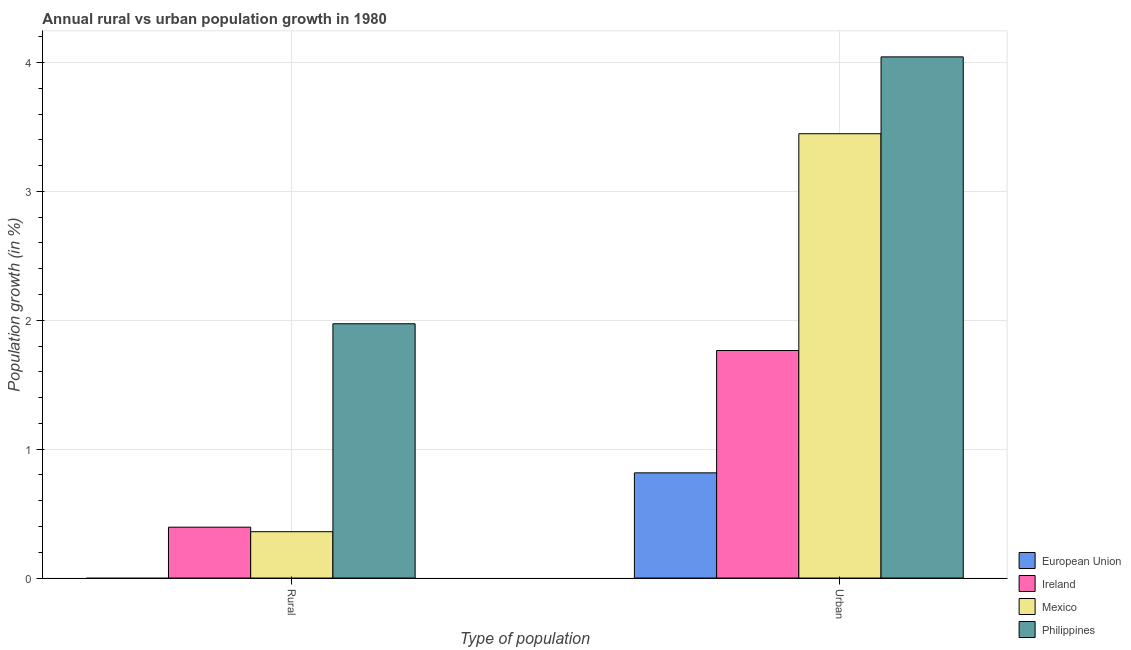How many different coloured bars are there?
Provide a short and direct response. 4. Are the number of bars on each tick of the X-axis equal?
Make the answer very short. No. How many bars are there on the 2nd tick from the right?
Keep it short and to the point. 3. What is the label of the 1st group of bars from the left?
Keep it short and to the point. Rural. What is the urban population growth in Mexico?
Your answer should be very brief. 3.45. Across all countries, what is the maximum rural population growth?
Ensure brevity in your answer.  1.97. Across all countries, what is the minimum rural population growth?
Provide a short and direct response. 0. In which country was the rural population growth maximum?
Keep it short and to the point. Philippines. What is the total urban population growth in the graph?
Give a very brief answer. 10.07. What is the difference between the rural population growth in Ireland and that in Mexico?
Your answer should be very brief. 0.04. What is the difference between the urban population growth in Ireland and the rural population growth in Philippines?
Provide a succinct answer. -0.21. What is the average urban population growth per country?
Your response must be concise. 2.52. What is the difference between the urban population growth and rural population growth in Philippines?
Provide a short and direct response. 2.07. What is the ratio of the urban population growth in Mexico to that in Philippines?
Your answer should be compact. 0.85. In how many countries, is the rural population growth greater than the average rural population growth taken over all countries?
Provide a succinct answer. 1. How many bars are there?
Your answer should be very brief. 7. Are all the bars in the graph horizontal?
Your answer should be compact. No. How many countries are there in the graph?
Offer a terse response. 4. What is the difference between two consecutive major ticks on the Y-axis?
Your answer should be very brief. 1. Are the values on the major ticks of Y-axis written in scientific E-notation?
Your answer should be very brief. No. Does the graph contain any zero values?
Provide a short and direct response. Yes. Where does the legend appear in the graph?
Provide a short and direct response. Bottom right. What is the title of the graph?
Make the answer very short. Annual rural vs urban population growth in 1980. What is the label or title of the X-axis?
Provide a succinct answer. Type of population. What is the label or title of the Y-axis?
Ensure brevity in your answer.  Population growth (in %). What is the Population growth (in %) of European Union in Rural?
Your answer should be compact. 0. What is the Population growth (in %) in Ireland in Rural?
Ensure brevity in your answer.  0.39. What is the Population growth (in %) of Mexico in Rural?
Offer a very short reply. 0.36. What is the Population growth (in %) in Philippines in Rural?
Provide a short and direct response. 1.97. What is the Population growth (in %) of European Union in Urban ?
Provide a succinct answer. 0.82. What is the Population growth (in %) of Ireland in Urban ?
Ensure brevity in your answer.  1.77. What is the Population growth (in %) in Mexico in Urban ?
Offer a very short reply. 3.45. What is the Population growth (in %) of Philippines in Urban ?
Make the answer very short. 4.04. Across all Type of population, what is the maximum Population growth (in %) in European Union?
Give a very brief answer. 0.82. Across all Type of population, what is the maximum Population growth (in %) of Ireland?
Provide a succinct answer. 1.77. Across all Type of population, what is the maximum Population growth (in %) of Mexico?
Your answer should be very brief. 3.45. Across all Type of population, what is the maximum Population growth (in %) in Philippines?
Ensure brevity in your answer.  4.04. Across all Type of population, what is the minimum Population growth (in %) in Ireland?
Provide a short and direct response. 0.39. Across all Type of population, what is the minimum Population growth (in %) of Mexico?
Provide a succinct answer. 0.36. Across all Type of population, what is the minimum Population growth (in %) in Philippines?
Provide a succinct answer. 1.97. What is the total Population growth (in %) of European Union in the graph?
Make the answer very short. 0.82. What is the total Population growth (in %) in Ireland in the graph?
Ensure brevity in your answer.  2.16. What is the total Population growth (in %) of Mexico in the graph?
Make the answer very short. 3.81. What is the total Population growth (in %) in Philippines in the graph?
Your answer should be very brief. 6.02. What is the difference between the Population growth (in %) of Ireland in Rural and that in Urban ?
Make the answer very short. -1.37. What is the difference between the Population growth (in %) of Mexico in Rural and that in Urban ?
Your answer should be very brief. -3.09. What is the difference between the Population growth (in %) of Philippines in Rural and that in Urban ?
Offer a very short reply. -2.07. What is the difference between the Population growth (in %) in Ireland in Rural and the Population growth (in %) in Mexico in Urban?
Offer a terse response. -3.05. What is the difference between the Population growth (in %) in Ireland in Rural and the Population growth (in %) in Philippines in Urban?
Provide a short and direct response. -3.65. What is the difference between the Population growth (in %) of Mexico in Rural and the Population growth (in %) of Philippines in Urban?
Your answer should be compact. -3.68. What is the average Population growth (in %) of European Union per Type of population?
Provide a succinct answer. 0.41. What is the average Population growth (in %) in Ireland per Type of population?
Ensure brevity in your answer.  1.08. What is the average Population growth (in %) of Mexico per Type of population?
Keep it short and to the point. 1.9. What is the average Population growth (in %) in Philippines per Type of population?
Keep it short and to the point. 3.01. What is the difference between the Population growth (in %) in Ireland and Population growth (in %) in Mexico in Rural?
Offer a terse response. 0.04. What is the difference between the Population growth (in %) in Ireland and Population growth (in %) in Philippines in Rural?
Give a very brief answer. -1.58. What is the difference between the Population growth (in %) of Mexico and Population growth (in %) of Philippines in Rural?
Your response must be concise. -1.61. What is the difference between the Population growth (in %) of European Union and Population growth (in %) of Ireland in Urban ?
Ensure brevity in your answer.  -0.95. What is the difference between the Population growth (in %) of European Union and Population growth (in %) of Mexico in Urban ?
Ensure brevity in your answer.  -2.63. What is the difference between the Population growth (in %) in European Union and Population growth (in %) in Philippines in Urban ?
Offer a terse response. -3.23. What is the difference between the Population growth (in %) of Ireland and Population growth (in %) of Mexico in Urban ?
Offer a terse response. -1.68. What is the difference between the Population growth (in %) in Ireland and Population growth (in %) in Philippines in Urban ?
Your answer should be very brief. -2.28. What is the difference between the Population growth (in %) of Mexico and Population growth (in %) of Philippines in Urban ?
Your response must be concise. -0.6. What is the ratio of the Population growth (in %) in Ireland in Rural to that in Urban ?
Make the answer very short. 0.22. What is the ratio of the Population growth (in %) in Mexico in Rural to that in Urban ?
Offer a very short reply. 0.1. What is the ratio of the Population growth (in %) of Philippines in Rural to that in Urban ?
Your answer should be compact. 0.49. What is the difference between the highest and the second highest Population growth (in %) in Ireland?
Your answer should be compact. 1.37. What is the difference between the highest and the second highest Population growth (in %) of Mexico?
Ensure brevity in your answer.  3.09. What is the difference between the highest and the second highest Population growth (in %) in Philippines?
Your response must be concise. 2.07. What is the difference between the highest and the lowest Population growth (in %) in European Union?
Keep it short and to the point. 0.82. What is the difference between the highest and the lowest Population growth (in %) in Ireland?
Offer a terse response. 1.37. What is the difference between the highest and the lowest Population growth (in %) in Mexico?
Your response must be concise. 3.09. What is the difference between the highest and the lowest Population growth (in %) in Philippines?
Ensure brevity in your answer.  2.07. 